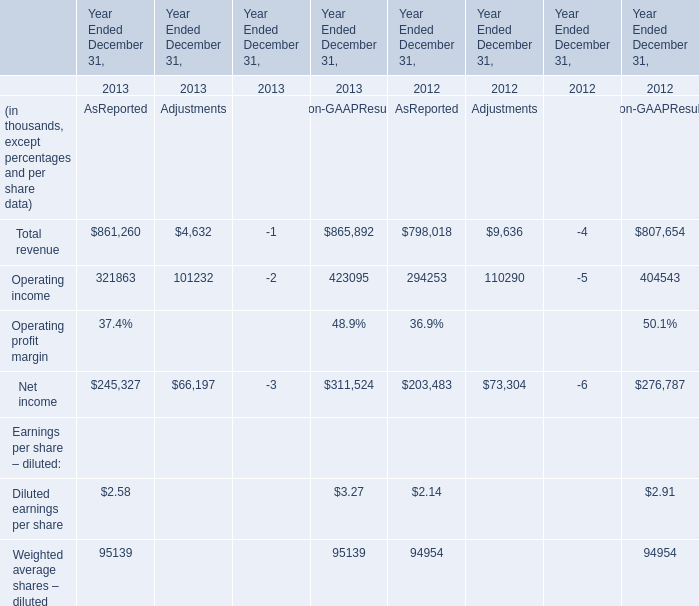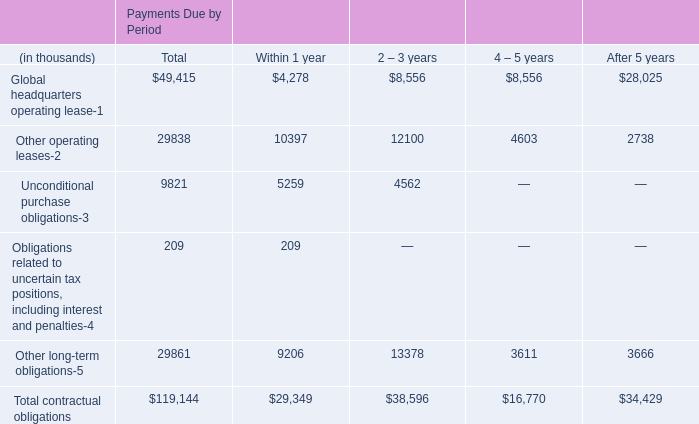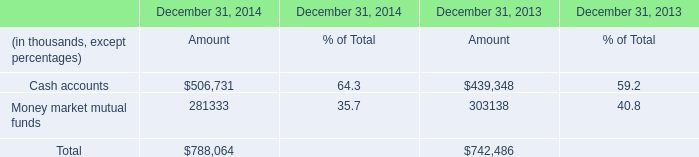what's the total amount of Net income of Year Ended December 31, 2013 Adjustments, and Cash accounts of December 31, 2014 Amount ? 
Computations: (66197.0 + 506731.0)
Answer: 572928.0. 